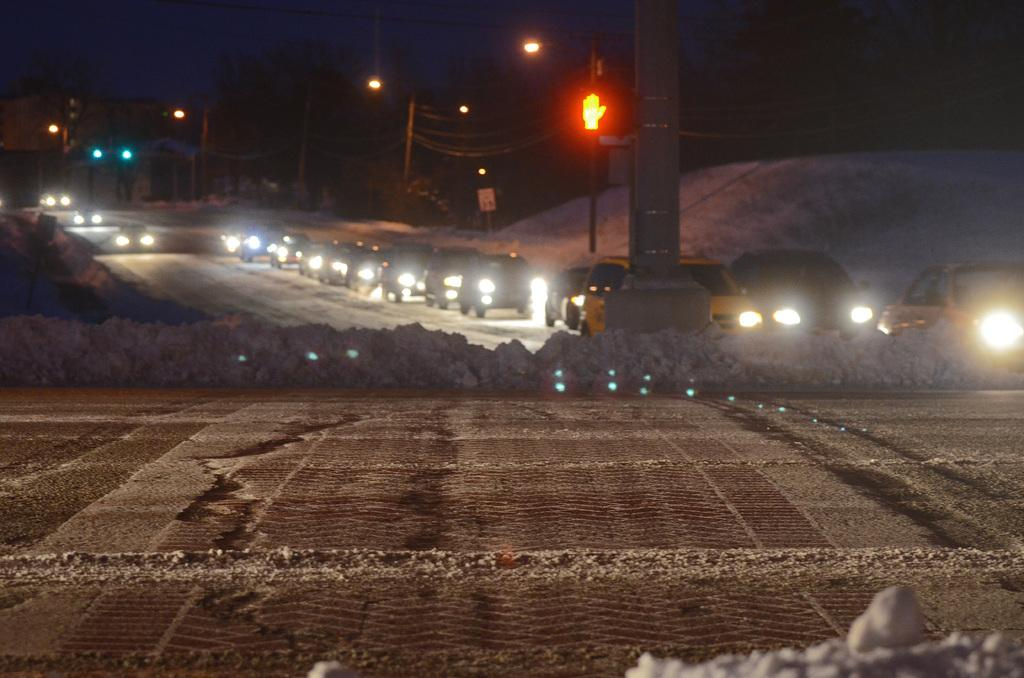What type of road is visible in the image? There is a mud road in the image. Are there any structures along the road? Yes, there are poles along the road. What is happening on the road in the image? Cars are riding on the road. What type of hydrant can be seen near the cars in the image? There is no hydrant present in the image; it only shows a mud road with poles and cars riding on it. 